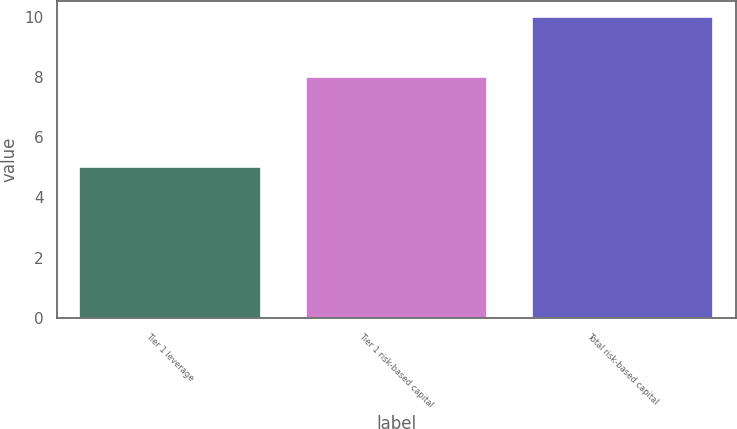Convert chart to OTSL. <chart><loc_0><loc_0><loc_500><loc_500><bar_chart><fcel>Tier 1 leverage<fcel>Tier 1 risk-based capital<fcel>Total risk-based capital<nl><fcel>5<fcel>8<fcel>10<nl></chart> 